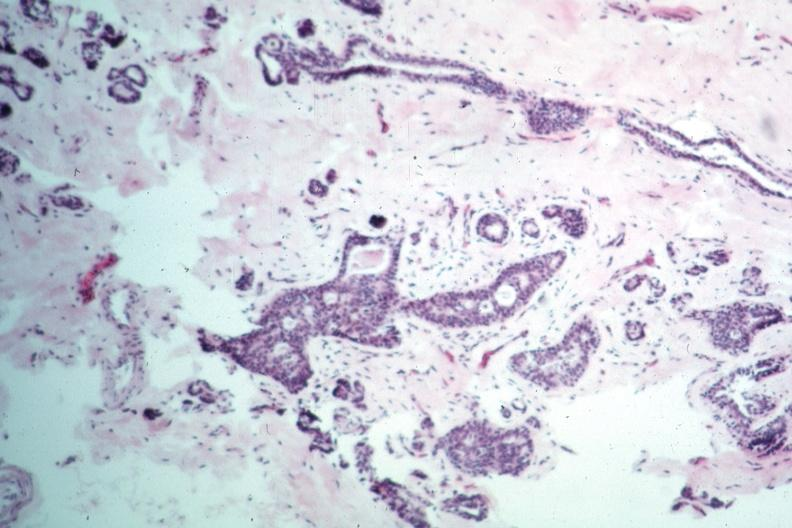what is present?
Answer the question using a single word or phrase. Breast 